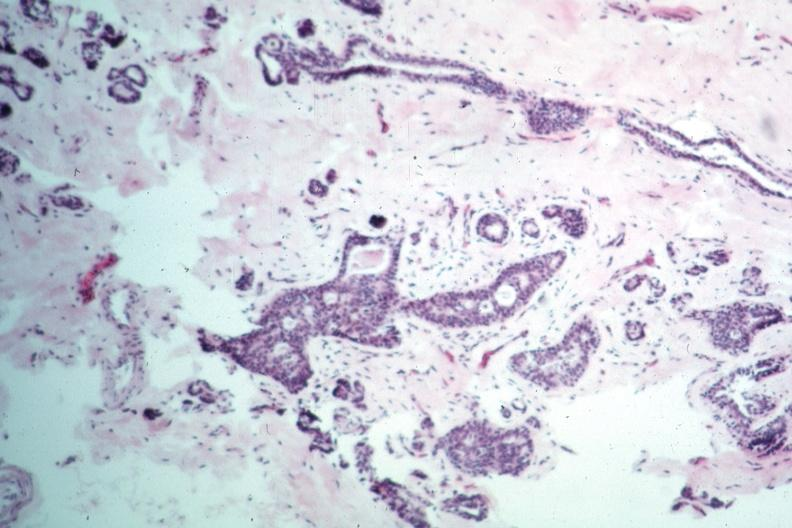what is present?
Answer the question using a single word or phrase. Breast 